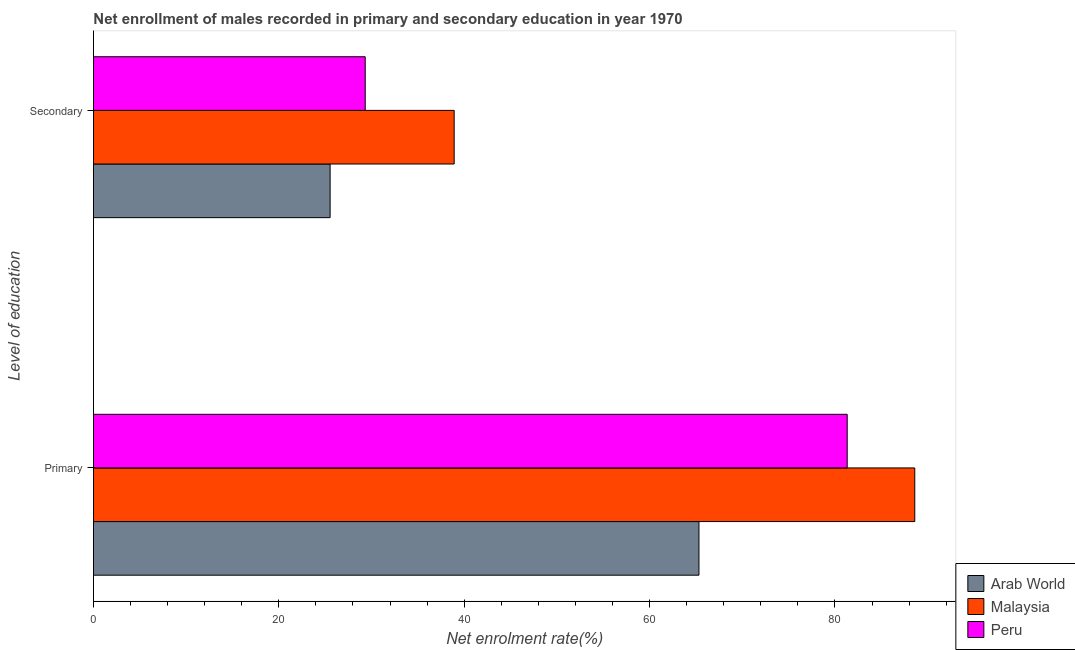Are the number of bars per tick equal to the number of legend labels?
Keep it short and to the point. Yes. What is the label of the 1st group of bars from the top?
Ensure brevity in your answer.  Secondary. What is the enrollment rate in secondary education in Peru?
Your answer should be compact. 29.32. Across all countries, what is the maximum enrollment rate in primary education?
Offer a very short reply. 88.61. Across all countries, what is the minimum enrollment rate in secondary education?
Provide a short and direct response. 25.53. In which country was the enrollment rate in secondary education maximum?
Offer a very short reply. Malaysia. In which country was the enrollment rate in primary education minimum?
Provide a succinct answer. Arab World. What is the total enrollment rate in secondary education in the graph?
Your answer should be compact. 93.77. What is the difference between the enrollment rate in secondary education in Peru and that in Malaysia?
Keep it short and to the point. -9.6. What is the difference between the enrollment rate in secondary education in Arab World and the enrollment rate in primary education in Peru?
Ensure brevity in your answer.  -55.79. What is the average enrollment rate in secondary education per country?
Offer a terse response. 31.26. What is the difference between the enrollment rate in secondary education and enrollment rate in primary education in Arab World?
Provide a succinct answer. -39.79. In how many countries, is the enrollment rate in secondary education greater than 72 %?
Offer a very short reply. 0. What is the ratio of the enrollment rate in secondary education in Peru to that in Arab World?
Your answer should be compact. 1.15. Is the enrollment rate in secondary education in Malaysia less than that in Peru?
Your answer should be compact. No. In how many countries, is the enrollment rate in primary education greater than the average enrollment rate in primary education taken over all countries?
Ensure brevity in your answer.  2. What does the 3rd bar from the top in Secondary represents?
Your response must be concise. Arab World. What does the 2nd bar from the bottom in Primary represents?
Make the answer very short. Malaysia. What is the difference between two consecutive major ticks on the X-axis?
Your response must be concise. 20. Are the values on the major ticks of X-axis written in scientific E-notation?
Keep it short and to the point. No. How are the legend labels stacked?
Provide a short and direct response. Vertical. What is the title of the graph?
Offer a very short reply. Net enrollment of males recorded in primary and secondary education in year 1970. What is the label or title of the X-axis?
Offer a very short reply. Net enrolment rate(%). What is the label or title of the Y-axis?
Provide a short and direct response. Level of education. What is the Net enrolment rate(%) of Arab World in Primary?
Offer a terse response. 65.33. What is the Net enrolment rate(%) of Malaysia in Primary?
Your answer should be compact. 88.61. What is the Net enrolment rate(%) in Peru in Primary?
Give a very brief answer. 81.32. What is the Net enrolment rate(%) of Arab World in Secondary?
Provide a succinct answer. 25.53. What is the Net enrolment rate(%) of Malaysia in Secondary?
Keep it short and to the point. 38.92. What is the Net enrolment rate(%) in Peru in Secondary?
Give a very brief answer. 29.32. Across all Level of education, what is the maximum Net enrolment rate(%) of Arab World?
Offer a very short reply. 65.33. Across all Level of education, what is the maximum Net enrolment rate(%) in Malaysia?
Give a very brief answer. 88.61. Across all Level of education, what is the maximum Net enrolment rate(%) in Peru?
Your answer should be compact. 81.32. Across all Level of education, what is the minimum Net enrolment rate(%) of Arab World?
Offer a very short reply. 25.53. Across all Level of education, what is the minimum Net enrolment rate(%) of Malaysia?
Provide a short and direct response. 38.92. Across all Level of education, what is the minimum Net enrolment rate(%) of Peru?
Offer a terse response. 29.32. What is the total Net enrolment rate(%) in Arab World in the graph?
Your answer should be compact. 90.86. What is the total Net enrolment rate(%) in Malaysia in the graph?
Make the answer very short. 127.53. What is the total Net enrolment rate(%) of Peru in the graph?
Give a very brief answer. 110.64. What is the difference between the Net enrolment rate(%) in Arab World in Primary and that in Secondary?
Keep it short and to the point. 39.79. What is the difference between the Net enrolment rate(%) of Malaysia in Primary and that in Secondary?
Make the answer very short. 49.7. What is the difference between the Net enrolment rate(%) of Peru in Primary and that in Secondary?
Make the answer very short. 52. What is the difference between the Net enrolment rate(%) in Arab World in Primary and the Net enrolment rate(%) in Malaysia in Secondary?
Give a very brief answer. 26.41. What is the difference between the Net enrolment rate(%) of Arab World in Primary and the Net enrolment rate(%) of Peru in Secondary?
Offer a very short reply. 36.01. What is the difference between the Net enrolment rate(%) of Malaysia in Primary and the Net enrolment rate(%) of Peru in Secondary?
Your response must be concise. 59.29. What is the average Net enrolment rate(%) in Arab World per Level of education?
Your answer should be very brief. 45.43. What is the average Net enrolment rate(%) of Malaysia per Level of education?
Provide a succinct answer. 63.76. What is the average Net enrolment rate(%) of Peru per Level of education?
Offer a very short reply. 55.32. What is the difference between the Net enrolment rate(%) of Arab World and Net enrolment rate(%) of Malaysia in Primary?
Keep it short and to the point. -23.29. What is the difference between the Net enrolment rate(%) in Arab World and Net enrolment rate(%) in Peru in Primary?
Keep it short and to the point. -15.99. What is the difference between the Net enrolment rate(%) of Malaysia and Net enrolment rate(%) of Peru in Primary?
Make the answer very short. 7.29. What is the difference between the Net enrolment rate(%) of Arab World and Net enrolment rate(%) of Malaysia in Secondary?
Give a very brief answer. -13.38. What is the difference between the Net enrolment rate(%) in Arab World and Net enrolment rate(%) in Peru in Secondary?
Offer a very short reply. -3.79. What is the difference between the Net enrolment rate(%) in Malaysia and Net enrolment rate(%) in Peru in Secondary?
Provide a short and direct response. 9.6. What is the ratio of the Net enrolment rate(%) of Arab World in Primary to that in Secondary?
Provide a short and direct response. 2.56. What is the ratio of the Net enrolment rate(%) in Malaysia in Primary to that in Secondary?
Offer a very short reply. 2.28. What is the ratio of the Net enrolment rate(%) in Peru in Primary to that in Secondary?
Offer a terse response. 2.77. What is the difference between the highest and the second highest Net enrolment rate(%) of Arab World?
Offer a very short reply. 39.79. What is the difference between the highest and the second highest Net enrolment rate(%) in Malaysia?
Ensure brevity in your answer.  49.7. What is the difference between the highest and the second highest Net enrolment rate(%) of Peru?
Provide a succinct answer. 52. What is the difference between the highest and the lowest Net enrolment rate(%) of Arab World?
Ensure brevity in your answer.  39.79. What is the difference between the highest and the lowest Net enrolment rate(%) of Malaysia?
Give a very brief answer. 49.7. What is the difference between the highest and the lowest Net enrolment rate(%) in Peru?
Offer a very short reply. 52. 